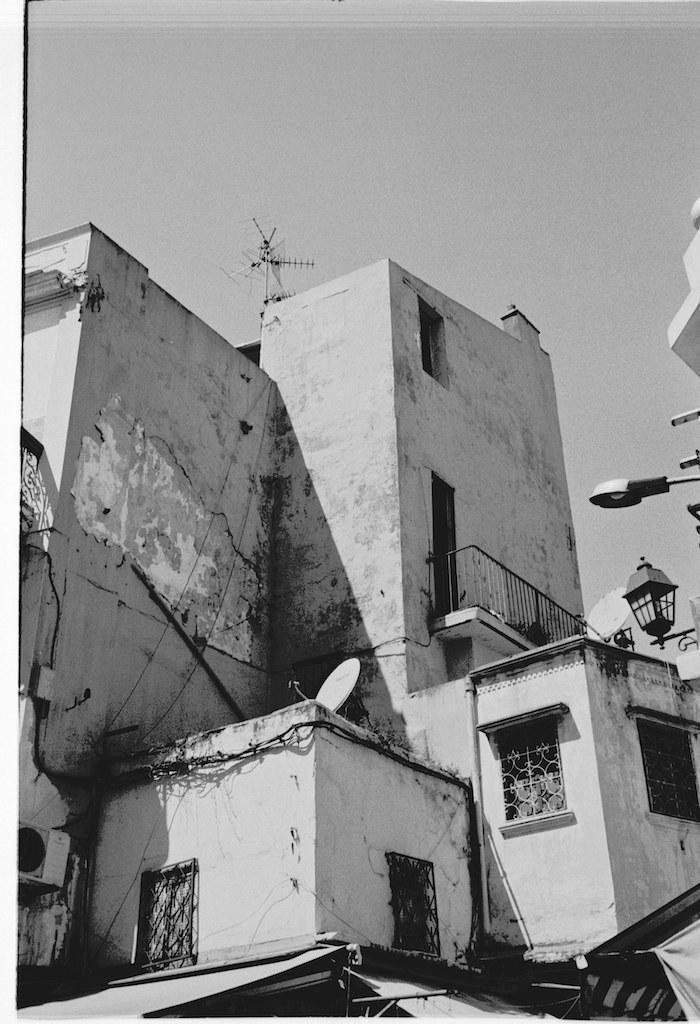Could you give a brief overview of what you see in this image? In the foreground of this black and white image, there is a building, where we can see walls, a railing, lamp, windows, antennas and few pipes. At the top, there is the sky. On the right, there is a light pole. 